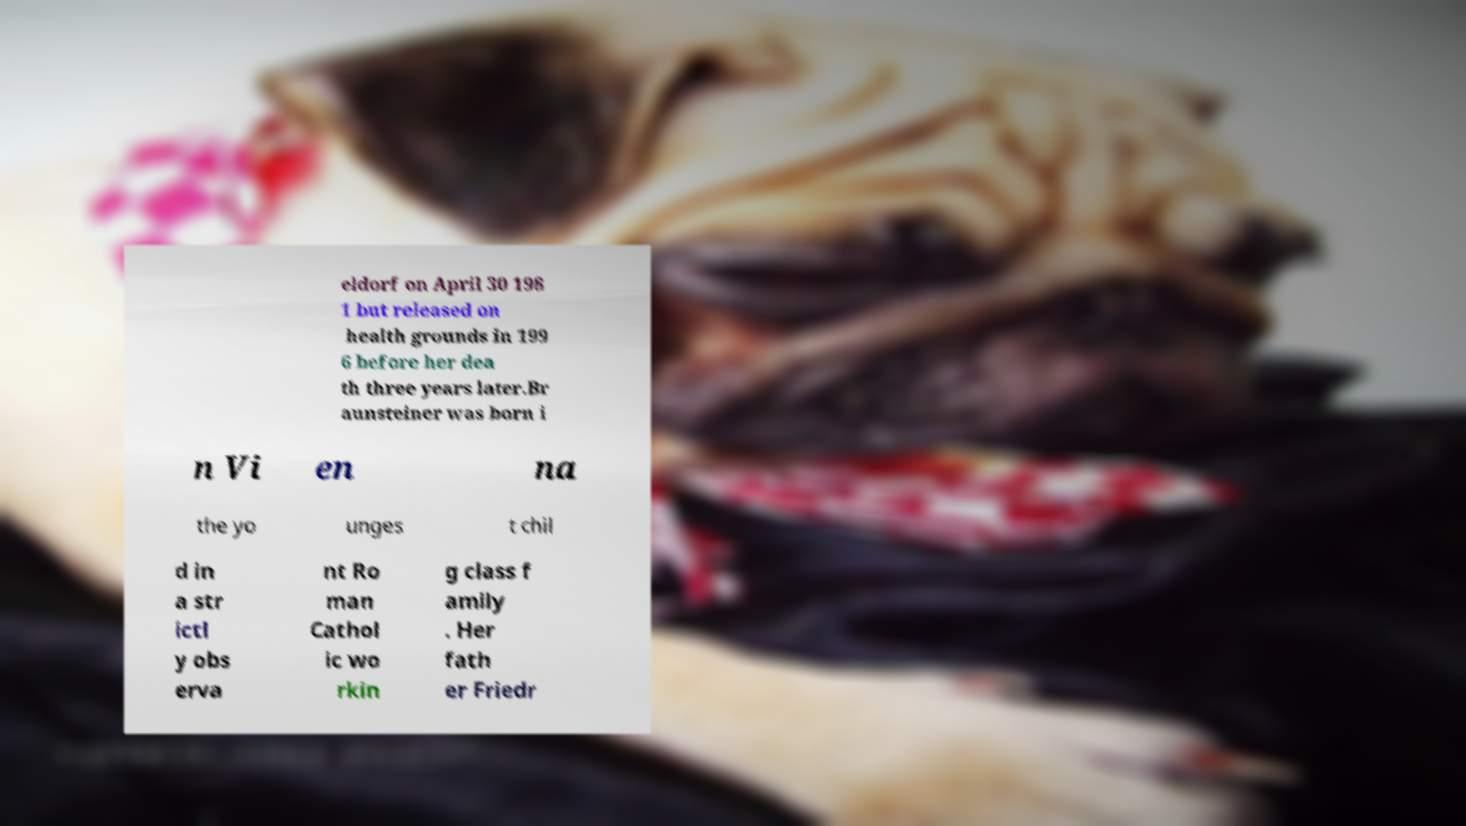Please read and relay the text visible in this image. What does it say? eldorf on April 30 198 1 but released on health grounds in 199 6 before her dea th three years later.Br aunsteiner was born i n Vi en na the yo unges t chil d in a str ictl y obs erva nt Ro man Cathol ic wo rkin g class f amily . Her fath er Friedr 